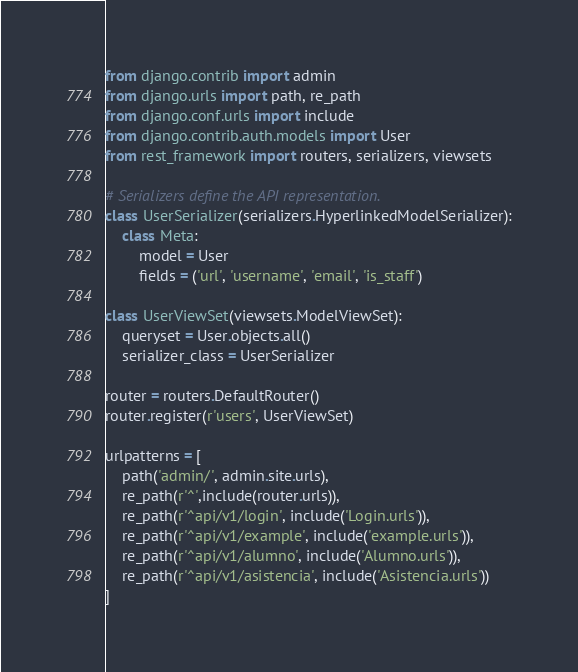<code> <loc_0><loc_0><loc_500><loc_500><_Python_>

from django.contrib import admin
from django.urls import path, re_path
from django.conf.urls import include
from django.contrib.auth.models import User
from rest_framework import routers, serializers, viewsets

# Serializers define the API representation.
class UserSerializer(serializers.HyperlinkedModelSerializer):
    class Meta:
        model = User
        fields = ('url', 'username', 'email', 'is_staff')

class UserViewSet(viewsets.ModelViewSet):
    queryset = User.objects.all()
    serializer_class = UserSerializer

router = routers.DefaultRouter()
router.register(r'users', UserViewSet)

urlpatterns = [
    path('admin/', admin.site.urls),
    re_path(r'^',include(router.urls)),
    re_path(r'^api/v1/login', include('Login.urls')),
    re_path(r'^api/v1/example', include('example.urls')),
    re_path(r'^api/v1/alumno', include('Alumno.urls')),
    re_path(r'^api/v1/asistencia', include('Asistencia.urls'))
]
</code> 